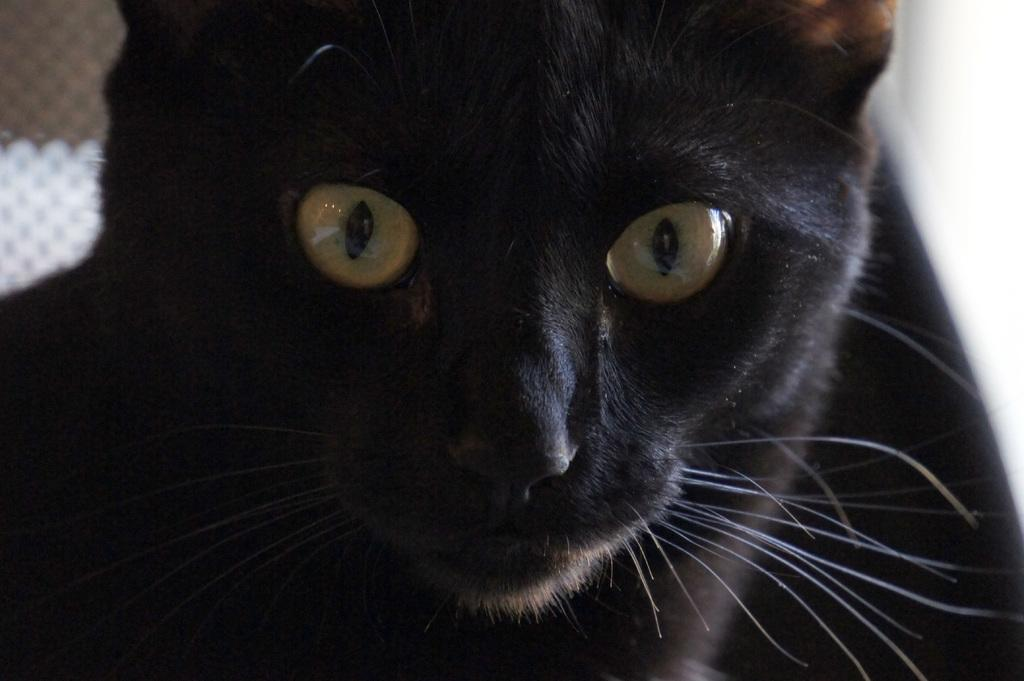What type of animal is present in the image? There is a black color cat in the image. Can you describe the cat's appearance? The cat is black in color. What type of cave can be seen in the background of the image? There is no cave present in the image; it features a black color cat. How does the yak interact with the cat in the image? There is no yak present in the image; it only features a black color cat. 